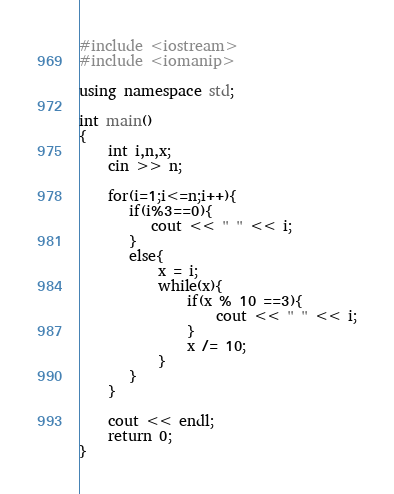Convert code to text. <code><loc_0><loc_0><loc_500><loc_500><_C++_>#include <iostream>
#include <iomanip>

using namespace std;

int main()
{
    int i,n,x;
    cin >> n;
    
    for(i=1;i<=n;i++){
       if(i%3==0){
          cout << " " << i;
       }
       else{
           x = i;
           while(x){
               if(x % 10 ==3){
                   cout << " " << i;
               }
               x /= 10;
           }
       }
    }

    cout << endl; 
    return 0;
}
</code> 